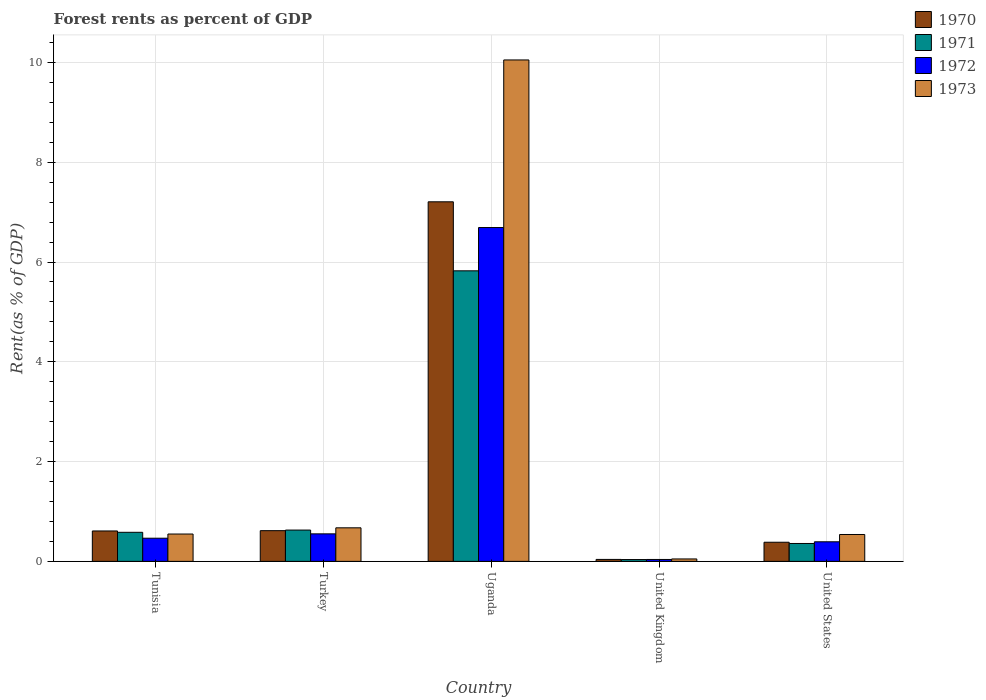How many groups of bars are there?
Keep it short and to the point. 5. Are the number of bars on each tick of the X-axis equal?
Offer a very short reply. Yes. How many bars are there on the 4th tick from the left?
Your response must be concise. 4. How many bars are there on the 1st tick from the right?
Ensure brevity in your answer.  4. What is the label of the 2nd group of bars from the left?
Offer a terse response. Turkey. What is the forest rent in 1973 in Tunisia?
Give a very brief answer. 0.55. Across all countries, what is the maximum forest rent in 1971?
Provide a succinct answer. 5.82. Across all countries, what is the minimum forest rent in 1972?
Provide a short and direct response. 0.04. In which country was the forest rent in 1970 maximum?
Your answer should be compact. Uganda. What is the total forest rent in 1972 in the graph?
Give a very brief answer. 8.14. What is the difference between the forest rent in 1972 in Uganda and that in United Kingdom?
Keep it short and to the point. 6.65. What is the difference between the forest rent in 1972 in Turkey and the forest rent in 1971 in Uganda?
Keep it short and to the point. -5.27. What is the average forest rent in 1971 per country?
Your response must be concise. 1.49. What is the difference between the forest rent of/in 1973 and forest rent of/in 1971 in United Kingdom?
Your answer should be very brief. 0.01. What is the ratio of the forest rent in 1971 in Uganda to that in United Kingdom?
Ensure brevity in your answer.  160.46. Is the difference between the forest rent in 1973 in Turkey and United Kingdom greater than the difference between the forest rent in 1971 in Turkey and United Kingdom?
Provide a short and direct response. Yes. What is the difference between the highest and the second highest forest rent in 1971?
Give a very brief answer. 0.04. What is the difference between the highest and the lowest forest rent in 1972?
Offer a very short reply. 6.65. Is the sum of the forest rent in 1972 in United Kingdom and United States greater than the maximum forest rent in 1973 across all countries?
Offer a very short reply. No. Is it the case that in every country, the sum of the forest rent in 1970 and forest rent in 1972 is greater than the sum of forest rent in 1971 and forest rent in 1973?
Give a very brief answer. No. Is it the case that in every country, the sum of the forest rent in 1972 and forest rent in 1970 is greater than the forest rent in 1971?
Provide a succinct answer. Yes. Are all the bars in the graph horizontal?
Ensure brevity in your answer.  No. What is the difference between two consecutive major ticks on the Y-axis?
Make the answer very short. 2. Does the graph contain grids?
Offer a terse response. Yes. How are the legend labels stacked?
Make the answer very short. Vertical. What is the title of the graph?
Your response must be concise. Forest rents as percent of GDP. What is the label or title of the Y-axis?
Your response must be concise. Rent(as % of GDP). What is the Rent(as % of GDP) in 1970 in Tunisia?
Your answer should be very brief. 0.61. What is the Rent(as % of GDP) of 1971 in Tunisia?
Offer a terse response. 0.58. What is the Rent(as % of GDP) of 1972 in Tunisia?
Your answer should be very brief. 0.46. What is the Rent(as % of GDP) in 1973 in Tunisia?
Make the answer very short. 0.55. What is the Rent(as % of GDP) of 1970 in Turkey?
Ensure brevity in your answer.  0.62. What is the Rent(as % of GDP) in 1971 in Turkey?
Your answer should be very brief. 0.63. What is the Rent(as % of GDP) in 1972 in Turkey?
Your answer should be very brief. 0.55. What is the Rent(as % of GDP) of 1973 in Turkey?
Your answer should be compact. 0.67. What is the Rent(as % of GDP) of 1970 in Uganda?
Ensure brevity in your answer.  7.21. What is the Rent(as % of GDP) of 1971 in Uganda?
Offer a very short reply. 5.82. What is the Rent(as % of GDP) of 1972 in Uganda?
Your answer should be compact. 6.69. What is the Rent(as % of GDP) of 1973 in Uganda?
Your answer should be compact. 10.05. What is the Rent(as % of GDP) in 1970 in United Kingdom?
Offer a very short reply. 0.04. What is the Rent(as % of GDP) of 1971 in United Kingdom?
Provide a succinct answer. 0.04. What is the Rent(as % of GDP) in 1972 in United Kingdom?
Provide a short and direct response. 0.04. What is the Rent(as % of GDP) in 1973 in United Kingdom?
Provide a short and direct response. 0.05. What is the Rent(as % of GDP) in 1970 in United States?
Your answer should be compact. 0.38. What is the Rent(as % of GDP) in 1971 in United States?
Your response must be concise. 0.36. What is the Rent(as % of GDP) of 1972 in United States?
Your answer should be very brief. 0.39. What is the Rent(as % of GDP) in 1973 in United States?
Offer a terse response. 0.54. Across all countries, what is the maximum Rent(as % of GDP) in 1970?
Ensure brevity in your answer.  7.21. Across all countries, what is the maximum Rent(as % of GDP) of 1971?
Make the answer very short. 5.82. Across all countries, what is the maximum Rent(as % of GDP) in 1972?
Provide a short and direct response. 6.69. Across all countries, what is the maximum Rent(as % of GDP) of 1973?
Provide a short and direct response. 10.05. Across all countries, what is the minimum Rent(as % of GDP) of 1970?
Give a very brief answer. 0.04. Across all countries, what is the minimum Rent(as % of GDP) in 1971?
Your answer should be very brief. 0.04. Across all countries, what is the minimum Rent(as % of GDP) of 1972?
Provide a succinct answer. 0.04. Across all countries, what is the minimum Rent(as % of GDP) of 1973?
Provide a succinct answer. 0.05. What is the total Rent(as % of GDP) in 1970 in the graph?
Your answer should be compact. 8.85. What is the total Rent(as % of GDP) in 1971 in the graph?
Your response must be concise. 7.43. What is the total Rent(as % of GDP) of 1972 in the graph?
Give a very brief answer. 8.14. What is the total Rent(as % of GDP) in 1973 in the graph?
Provide a succinct answer. 11.86. What is the difference between the Rent(as % of GDP) of 1970 in Tunisia and that in Turkey?
Provide a short and direct response. -0.01. What is the difference between the Rent(as % of GDP) of 1971 in Tunisia and that in Turkey?
Give a very brief answer. -0.04. What is the difference between the Rent(as % of GDP) in 1972 in Tunisia and that in Turkey?
Offer a terse response. -0.09. What is the difference between the Rent(as % of GDP) in 1973 in Tunisia and that in Turkey?
Your answer should be compact. -0.12. What is the difference between the Rent(as % of GDP) of 1970 in Tunisia and that in Uganda?
Ensure brevity in your answer.  -6.6. What is the difference between the Rent(as % of GDP) in 1971 in Tunisia and that in Uganda?
Make the answer very short. -5.24. What is the difference between the Rent(as % of GDP) in 1972 in Tunisia and that in Uganda?
Offer a very short reply. -6.23. What is the difference between the Rent(as % of GDP) of 1973 in Tunisia and that in Uganda?
Keep it short and to the point. -9.5. What is the difference between the Rent(as % of GDP) in 1970 in Tunisia and that in United Kingdom?
Your response must be concise. 0.57. What is the difference between the Rent(as % of GDP) in 1971 in Tunisia and that in United Kingdom?
Your answer should be very brief. 0.55. What is the difference between the Rent(as % of GDP) of 1972 in Tunisia and that in United Kingdom?
Give a very brief answer. 0.43. What is the difference between the Rent(as % of GDP) of 1973 in Tunisia and that in United Kingdom?
Your response must be concise. 0.5. What is the difference between the Rent(as % of GDP) in 1970 in Tunisia and that in United States?
Provide a short and direct response. 0.23. What is the difference between the Rent(as % of GDP) of 1971 in Tunisia and that in United States?
Make the answer very short. 0.22. What is the difference between the Rent(as % of GDP) of 1972 in Tunisia and that in United States?
Offer a very short reply. 0.07. What is the difference between the Rent(as % of GDP) in 1973 in Tunisia and that in United States?
Offer a terse response. 0.01. What is the difference between the Rent(as % of GDP) in 1970 in Turkey and that in Uganda?
Give a very brief answer. -6.59. What is the difference between the Rent(as % of GDP) of 1971 in Turkey and that in Uganda?
Ensure brevity in your answer.  -5.2. What is the difference between the Rent(as % of GDP) of 1972 in Turkey and that in Uganda?
Offer a terse response. -6.14. What is the difference between the Rent(as % of GDP) in 1973 in Turkey and that in Uganda?
Keep it short and to the point. -9.38. What is the difference between the Rent(as % of GDP) in 1970 in Turkey and that in United Kingdom?
Offer a very short reply. 0.58. What is the difference between the Rent(as % of GDP) in 1971 in Turkey and that in United Kingdom?
Keep it short and to the point. 0.59. What is the difference between the Rent(as % of GDP) of 1972 in Turkey and that in United Kingdom?
Your response must be concise. 0.51. What is the difference between the Rent(as % of GDP) of 1973 in Turkey and that in United Kingdom?
Provide a succinct answer. 0.62. What is the difference between the Rent(as % of GDP) in 1970 in Turkey and that in United States?
Offer a very short reply. 0.23. What is the difference between the Rent(as % of GDP) in 1971 in Turkey and that in United States?
Your answer should be compact. 0.27. What is the difference between the Rent(as % of GDP) in 1972 in Turkey and that in United States?
Your answer should be compact. 0.16. What is the difference between the Rent(as % of GDP) in 1973 in Turkey and that in United States?
Provide a short and direct response. 0.13. What is the difference between the Rent(as % of GDP) in 1970 in Uganda and that in United Kingdom?
Ensure brevity in your answer.  7.17. What is the difference between the Rent(as % of GDP) of 1971 in Uganda and that in United Kingdom?
Your answer should be very brief. 5.79. What is the difference between the Rent(as % of GDP) of 1972 in Uganda and that in United Kingdom?
Ensure brevity in your answer.  6.65. What is the difference between the Rent(as % of GDP) in 1973 in Uganda and that in United Kingdom?
Ensure brevity in your answer.  10. What is the difference between the Rent(as % of GDP) in 1970 in Uganda and that in United States?
Provide a short and direct response. 6.82. What is the difference between the Rent(as % of GDP) in 1971 in Uganda and that in United States?
Keep it short and to the point. 5.47. What is the difference between the Rent(as % of GDP) of 1972 in Uganda and that in United States?
Keep it short and to the point. 6.3. What is the difference between the Rent(as % of GDP) in 1973 in Uganda and that in United States?
Your response must be concise. 9.51. What is the difference between the Rent(as % of GDP) in 1970 in United Kingdom and that in United States?
Your answer should be compact. -0.34. What is the difference between the Rent(as % of GDP) in 1971 in United Kingdom and that in United States?
Make the answer very short. -0.32. What is the difference between the Rent(as % of GDP) of 1972 in United Kingdom and that in United States?
Provide a succinct answer. -0.35. What is the difference between the Rent(as % of GDP) in 1973 in United Kingdom and that in United States?
Provide a short and direct response. -0.49. What is the difference between the Rent(as % of GDP) of 1970 in Tunisia and the Rent(as % of GDP) of 1971 in Turkey?
Ensure brevity in your answer.  -0.02. What is the difference between the Rent(as % of GDP) of 1970 in Tunisia and the Rent(as % of GDP) of 1972 in Turkey?
Offer a terse response. 0.06. What is the difference between the Rent(as % of GDP) of 1970 in Tunisia and the Rent(as % of GDP) of 1973 in Turkey?
Your answer should be compact. -0.06. What is the difference between the Rent(as % of GDP) in 1971 in Tunisia and the Rent(as % of GDP) in 1972 in Turkey?
Make the answer very short. 0.03. What is the difference between the Rent(as % of GDP) of 1971 in Tunisia and the Rent(as % of GDP) of 1973 in Turkey?
Your answer should be compact. -0.09. What is the difference between the Rent(as % of GDP) in 1972 in Tunisia and the Rent(as % of GDP) in 1973 in Turkey?
Your answer should be compact. -0.21. What is the difference between the Rent(as % of GDP) in 1970 in Tunisia and the Rent(as % of GDP) in 1971 in Uganda?
Offer a terse response. -5.21. What is the difference between the Rent(as % of GDP) of 1970 in Tunisia and the Rent(as % of GDP) of 1972 in Uganda?
Make the answer very short. -6.08. What is the difference between the Rent(as % of GDP) in 1970 in Tunisia and the Rent(as % of GDP) in 1973 in Uganda?
Provide a short and direct response. -9.44. What is the difference between the Rent(as % of GDP) in 1971 in Tunisia and the Rent(as % of GDP) in 1972 in Uganda?
Offer a terse response. -6.11. What is the difference between the Rent(as % of GDP) of 1971 in Tunisia and the Rent(as % of GDP) of 1973 in Uganda?
Provide a succinct answer. -9.47. What is the difference between the Rent(as % of GDP) of 1972 in Tunisia and the Rent(as % of GDP) of 1973 in Uganda?
Provide a succinct answer. -9.59. What is the difference between the Rent(as % of GDP) in 1970 in Tunisia and the Rent(as % of GDP) in 1971 in United Kingdom?
Provide a short and direct response. 0.57. What is the difference between the Rent(as % of GDP) in 1970 in Tunisia and the Rent(as % of GDP) in 1972 in United Kingdom?
Provide a succinct answer. 0.57. What is the difference between the Rent(as % of GDP) in 1970 in Tunisia and the Rent(as % of GDP) in 1973 in United Kingdom?
Offer a very short reply. 0.56. What is the difference between the Rent(as % of GDP) of 1971 in Tunisia and the Rent(as % of GDP) of 1972 in United Kingdom?
Ensure brevity in your answer.  0.54. What is the difference between the Rent(as % of GDP) of 1971 in Tunisia and the Rent(as % of GDP) of 1973 in United Kingdom?
Offer a terse response. 0.53. What is the difference between the Rent(as % of GDP) of 1972 in Tunisia and the Rent(as % of GDP) of 1973 in United Kingdom?
Provide a succinct answer. 0.42. What is the difference between the Rent(as % of GDP) in 1970 in Tunisia and the Rent(as % of GDP) in 1971 in United States?
Give a very brief answer. 0.25. What is the difference between the Rent(as % of GDP) in 1970 in Tunisia and the Rent(as % of GDP) in 1972 in United States?
Provide a short and direct response. 0.22. What is the difference between the Rent(as % of GDP) in 1970 in Tunisia and the Rent(as % of GDP) in 1973 in United States?
Your answer should be very brief. 0.07. What is the difference between the Rent(as % of GDP) of 1971 in Tunisia and the Rent(as % of GDP) of 1972 in United States?
Keep it short and to the point. 0.19. What is the difference between the Rent(as % of GDP) of 1971 in Tunisia and the Rent(as % of GDP) of 1973 in United States?
Give a very brief answer. 0.04. What is the difference between the Rent(as % of GDP) in 1972 in Tunisia and the Rent(as % of GDP) in 1973 in United States?
Provide a short and direct response. -0.07. What is the difference between the Rent(as % of GDP) of 1970 in Turkey and the Rent(as % of GDP) of 1971 in Uganda?
Make the answer very short. -5.21. What is the difference between the Rent(as % of GDP) in 1970 in Turkey and the Rent(as % of GDP) in 1972 in Uganda?
Your response must be concise. -6.08. What is the difference between the Rent(as % of GDP) in 1970 in Turkey and the Rent(as % of GDP) in 1973 in Uganda?
Your answer should be compact. -9.44. What is the difference between the Rent(as % of GDP) of 1971 in Turkey and the Rent(as % of GDP) of 1972 in Uganda?
Make the answer very short. -6.06. What is the difference between the Rent(as % of GDP) in 1971 in Turkey and the Rent(as % of GDP) in 1973 in Uganda?
Offer a terse response. -9.42. What is the difference between the Rent(as % of GDP) in 1972 in Turkey and the Rent(as % of GDP) in 1973 in Uganda?
Your answer should be compact. -9.5. What is the difference between the Rent(as % of GDP) of 1970 in Turkey and the Rent(as % of GDP) of 1971 in United Kingdom?
Offer a very short reply. 0.58. What is the difference between the Rent(as % of GDP) of 1970 in Turkey and the Rent(as % of GDP) of 1972 in United Kingdom?
Provide a succinct answer. 0.58. What is the difference between the Rent(as % of GDP) in 1970 in Turkey and the Rent(as % of GDP) in 1973 in United Kingdom?
Your response must be concise. 0.57. What is the difference between the Rent(as % of GDP) of 1971 in Turkey and the Rent(as % of GDP) of 1972 in United Kingdom?
Your answer should be compact. 0.59. What is the difference between the Rent(as % of GDP) in 1971 in Turkey and the Rent(as % of GDP) in 1973 in United Kingdom?
Your answer should be very brief. 0.58. What is the difference between the Rent(as % of GDP) in 1972 in Turkey and the Rent(as % of GDP) in 1973 in United Kingdom?
Offer a very short reply. 0.5. What is the difference between the Rent(as % of GDP) in 1970 in Turkey and the Rent(as % of GDP) in 1971 in United States?
Offer a terse response. 0.26. What is the difference between the Rent(as % of GDP) in 1970 in Turkey and the Rent(as % of GDP) in 1972 in United States?
Provide a short and direct response. 0.22. What is the difference between the Rent(as % of GDP) in 1970 in Turkey and the Rent(as % of GDP) in 1973 in United States?
Keep it short and to the point. 0.08. What is the difference between the Rent(as % of GDP) of 1971 in Turkey and the Rent(as % of GDP) of 1972 in United States?
Provide a short and direct response. 0.23. What is the difference between the Rent(as % of GDP) in 1971 in Turkey and the Rent(as % of GDP) in 1973 in United States?
Your answer should be compact. 0.09. What is the difference between the Rent(as % of GDP) in 1972 in Turkey and the Rent(as % of GDP) in 1973 in United States?
Your response must be concise. 0.01. What is the difference between the Rent(as % of GDP) of 1970 in Uganda and the Rent(as % of GDP) of 1971 in United Kingdom?
Keep it short and to the point. 7.17. What is the difference between the Rent(as % of GDP) of 1970 in Uganda and the Rent(as % of GDP) of 1972 in United Kingdom?
Give a very brief answer. 7.17. What is the difference between the Rent(as % of GDP) in 1970 in Uganda and the Rent(as % of GDP) in 1973 in United Kingdom?
Offer a terse response. 7.16. What is the difference between the Rent(as % of GDP) of 1971 in Uganda and the Rent(as % of GDP) of 1972 in United Kingdom?
Offer a very short reply. 5.79. What is the difference between the Rent(as % of GDP) in 1971 in Uganda and the Rent(as % of GDP) in 1973 in United Kingdom?
Your answer should be very brief. 5.78. What is the difference between the Rent(as % of GDP) of 1972 in Uganda and the Rent(as % of GDP) of 1973 in United Kingdom?
Provide a short and direct response. 6.64. What is the difference between the Rent(as % of GDP) in 1970 in Uganda and the Rent(as % of GDP) in 1971 in United States?
Make the answer very short. 6.85. What is the difference between the Rent(as % of GDP) in 1970 in Uganda and the Rent(as % of GDP) in 1972 in United States?
Provide a short and direct response. 6.81. What is the difference between the Rent(as % of GDP) of 1970 in Uganda and the Rent(as % of GDP) of 1973 in United States?
Your response must be concise. 6.67. What is the difference between the Rent(as % of GDP) of 1971 in Uganda and the Rent(as % of GDP) of 1972 in United States?
Offer a very short reply. 5.43. What is the difference between the Rent(as % of GDP) of 1971 in Uganda and the Rent(as % of GDP) of 1973 in United States?
Your response must be concise. 5.29. What is the difference between the Rent(as % of GDP) in 1972 in Uganda and the Rent(as % of GDP) in 1973 in United States?
Ensure brevity in your answer.  6.15. What is the difference between the Rent(as % of GDP) in 1970 in United Kingdom and the Rent(as % of GDP) in 1971 in United States?
Give a very brief answer. -0.32. What is the difference between the Rent(as % of GDP) of 1970 in United Kingdom and the Rent(as % of GDP) of 1972 in United States?
Ensure brevity in your answer.  -0.35. What is the difference between the Rent(as % of GDP) of 1970 in United Kingdom and the Rent(as % of GDP) of 1973 in United States?
Your response must be concise. -0.5. What is the difference between the Rent(as % of GDP) of 1971 in United Kingdom and the Rent(as % of GDP) of 1972 in United States?
Your answer should be compact. -0.36. What is the difference between the Rent(as % of GDP) of 1971 in United Kingdom and the Rent(as % of GDP) of 1973 in United States?
Your response must be concise. -0.5. What is the difference between the Rent(as % of GDP) in 1972 in United Kingdom and the Rent(as % of GDP) in 1973 in United States?
Make the answer very short. -0.5. What is the average Rent(as % of GDP) of 1970 per country?
Your answer should be very brief. 1.77. What is the average Rent(as % of GDP) in 1971 per country?
Offer a very short reply. 1.49. What is the average Rent(as % of GDP) in 1972 per country?
Your answer should be compact. 1.63. What is the average Rent(as % of GDP) in 1973 per country?
Provide a succinct answer. 2.37. What is the difference between the Rent(as % of GDP) of 1970 and Rent(as % of GDP) of 1971 in Tunisia?
Make the answer very short. 0.03. What is the difference between the Rent(as % of GDP) of 1970 and Rent(as % of GDP) of 1972 in Tunisia?
Offer a very short reply. 0.15. What is the difference between the Rent(as % of GDP) in 1970 and Rent(as % of GDP) in 1973 in Tunisia?
Give a very brief answer. 0.06. What is the difference between the Rent(as % of GDP) of 1971 and Rent(as % of GDP) of 1972 in Tunisia?
Make the answer very short. 0.12. What is the difference between the Rent(as % of GDP) of 1971 and Rent(as % of GDP) of 1973 in Tunisia?
Your answer should be compact. 0.03. What is the difference between the Rent(as % of GDP) of 1972 and Rent(as % of GDP) of 1973 in Tunisia?
Offer a very short reply. -0.08. What is the difference between the Rent(as % of GDP) in 1970 and Rent(as % of GDP) in 1971 in Turkey?
Offer a very short reply. -0.01. What is the difference between the Rent(as % of GDP) in 1970 and Rent(as % of GDP) in 1972 in Turkey?
Your response must be concise. 0.06. What is the difference between the Rent(as % of GDP) in 1970 and Rent(as % of GDP) in 1973 in Turkey?
Keep it short and to the point. -0.06. What is the difference between the Rent(as % of GDP) of 1971 and Rent(as % of GDP) of 1972 in Turkey?
Your response must be concise. 0.08. What is the difference between the Rent(as % of GDP) of 1971 and Rent(as % of GDP) of 1973 in Turkey?
Provide a succinct answer. -0.05. What is the difference between the Rent(as % of GDP) in 1972 and Rent(as % of GDP) in 1973 in Turkey?
Keep it short and to the point. -0.12. What is the difference between the Rent(as % of GDP) of 1970 and Rent(as % of GDP) of 1971 in Uganda?
Keep it short and to the point. 1.38. What is the difference between the Rent(as % of GDP) in 1970 and Rent(as % of GDP) in 1972 in Uganda?
Your answer should be very brief. 0.52. What is the difference between the Rent(as % of GDP) of 1970 and Rent(as % of GDP) of 1973 in Uganda?
Ensure brevity in your answer.  -2.84. What is the difference between the Rent(as % of GDP) of 1971 and Rent(as % of GDP) of 1972 in Uganda?
Your response must be concise. -0.87. What is the difference between the Rent(as % of GDP) in 1971 and Rent(as % of GDP) in 1973 in Uganda?
Your answer should be very brief. -4.23. What is the difference between the Rent(as % of GDP) of 1972 and Rent(as % of GDP) of 1973 in Uganda?
Keep it short and to the point. -3.36. What is the difference between the Rent(as % of GDP) in 1970 and Rent(as % of GDP) in 1971 in United Kingdom?
Offer a terse response. 0. What is the difference between the Rent(as % of GDP) in 1970 and Rent(as % of GDP) in 1972 in United Kingdom?
Give a very brief answer. 0. What is the difference between the Rent(as % of GDP) in 1970 and Rent(as % of GDP) in 1973 in United Kingdom?
Provide a succinct answer. -0.01. What is the difference between the Rent(as % of GDP) in 1971 and Rent(as % of GDP) in 1972 in United Kingdom?
Give a very brief answer. -0. What is the difference between the Rent(as % of GDP) in 1971 and Rent(as % of GDP) in 1973 in United Kingdom?
Keep it short and to the point. -0.01. What is the difference between the Rent(as % of GDP) of 1972 and Rent(as % of GDP) of 1973 in United Kingdom?
Keep it short and to the point. -0.01. What is the difference between the Rent(as % of GDP) of 1970 and Rent(as % of GDP) of 1971 in United States?
Ensure brevity in your answer.  0.02. What is the difference between the Rent(as % of GDP) in 1970 and Rent(as % of GDP) in 1972 in United States?
Provide a succinct answer. -0.01. What is the difference between the Rent(as % of GDP) of 1970 and Rent(as % of GDP) of 1973 in United States?
Your response must be concise. -0.16. What is the difference between the Rent(as % of GDP) of 1971 and Rent(as % of GDP) of 1972 in United States?
Offer a very short reply. -0.03. What is the difference between the Rent(as % of GDP) of 1971 and Rent(as % of GDP) of 1973 in United States?
Give a very brief answer. -0.18. What is the difference between the Rent(as % of GDP) of 1972 and Rent(as % of GDP) of 1973 in United States?
Your answer should be very brief. -0.15. What is the ratio of the Rent(as % of GDP) of 1970 in Tunisia to that in Turkey?
Make the answer very short. 0.99. What is the ratio of the Rent(as % of GDP) in 1971 in Tunisia to that in Turkey?
Your answer should be very brief. 0.93. What is the ratio of the Rent(as % of GDP) in 1972 in Tunisia to that in Turkey?
Keep it short and to the point. 0.84. What is the ratio of the Rent(as % of GDP) of 1973 in Tunisia to that in Turkey?
Provide a short and direct response. 0.81. What is the ratio of the Rent(as % of GDP) in 1970 in Tunisia to that in Uganda?
Ensure brevity in your answer.  0.08. What is the ratio of the Rent(as % of GDP) in 1972 in Tunisia to that in Uganda?
Provide a succinct answer. 0.07. What is the ratio of the Rent(as % of GDP) of 1973 in Tunisia to that in Uganda?
Keep it short and to the point. 0.05. What is the ratio of the Rent(as % of GDP) of 1970 in Tunisia to that in United Kingdom?
Provide a short and direct response. 15.63. What is the ratio of the Rent(as % of GDP) of 1971 in Tunisia to that in United Kingdom?
Offer a terse response. 16.05. What is the ratio of the Rent(as % of GDP) in 1972 in Tunisia to that in United Kingdom?
Provide a short and direct response. 12.2. What is the ratio of the Rent(as % of GDP) in 1973 in Tunisia to that in United Kingdom?
Ensure brevity in your answer.  11.27. What is the ratio of the Rent(as % of GDP) of 1970 in Tunisia to that in United States?
Offer a terse response. 1.59. What is the ratio of the Rent(as % of GDP) in 1971 in Tunisia to that in United States?
Your response must be concise. 1.62. What is the ratio of the Rent(as % of GDP) of 1972 in Tunisia to that in United States?
Make the answer very short. 1.18. What is the ratio of the Rent(as % of GDP) of 1973 in Tunisia to that in United States?
Provide a succinct answer. 1.02. What is the ratio of the Rent(as % of GDP) in 1970 in Turkey to that in Uganda?
Your answer should be very brief. 0.09. What is the ratio of the Rent(as % of GDP) in 1971 in Turkey to that in Uganda?
Offer a very short reply. 0.11. What is the ratio of the Rent(as % of GDP) in 1972 in Turkey to that in Uganda?
Keep it short and to the point. 0.08. What is the ratio of the Rent(as % of GDP) in 1973 in Turkey to that in Uganda?
Your response must be concise. 0.07. What is the ratio of the Rent(as % of GDP) of 1970 in Turkey to that in United Kingdom?
Ensure brevity in your answer.  15.78. What is the ratio of the Rent(as % of GDP) in 1971 in Turkey to that in United Kingdom?
Ensure brevity in your answer.  17.29. What is the ratio of the Rent(as % of GDP) in 1972 in Turkey to that in United Kingdom?
Keep it short and to the point. 14.49. What is the ratio of the Rent(as % of GDP) of 1973 in Turkey to that in United Kingdom?
Make the answer very short. 13.83. What is the ratio of the Rent(as % of GDP) in 1970 in Turkey to that in United States?
Offer a very short reply. 1.61. What is the ratio of the Rent(as % of GDP) of 1971 in Turkey to that in United States?
Offer a very short reply. 1.75. What is the ratio of the Rent(as % of GDP) in 1972 in Turkey to that in United States?
Provide a succinct answer. 1.41. What is the ratio of the Rent(as % of GDP) of 1973 in Turkey to that in United States?
Your answer should be very brief. 1.25. What is the ratio of the Rent(as % of GDP) in 1970 in Uganda to that in United Kingdom?
Provide a succinct answer. 184.81. What is the ratio of the Rent(as % of GDP) of 1971 in Uganda to that in United Kingdom?
Keep it short and to the point. 160.46. What is the ratio of the Rent(as % of GDP) in 1972 in Uganda to that in United Kingdom?
Make the answer very short. 175.86. What is the ratio of the Rent(as % of GDP) in 1973 in Uganda to that in United Kingdom?
Offer a very short reply. 206.75. What is the ratio of the Rent(as % of GDP) of 1970 in Uganda to that in United States?
Give a very brief answer. 18.8. What is the ratio of the Rent(as % of GDP) in 1971 in Uganda to that in United States?
Give a very brief answer. 16.24. What is the ratio of the Rent(as % of GDP) in 1972 in Uganda to that in United States?
Your answer should be compact. 17.05. What is the ratio of the Rent(as % of GDP) in 1973 in Uganda to that in United States?
Make the answer very short. 18.66. What is the ratio of the Rent(as % of GDP) in 1970 in United Kingdom to that in United States?
Provide a succinct answer. 0.1. What is the ratio of the Rent(as % of GDP) in 1971 in United Kingdom to that in United States?
Your answer should be very brief. 0.1. What is the ratio of the Rent(as % of GDP) of 1972 in United Kingdom to that in United States?
Make the answer very short. 0.1. What is the ratio of the Rent(as % of GDP) of 1973 in United Kingdom to that in United States?
Keep it short and to the point. 0.09. What is the difference between the highest and the second highest Rent(as % of GDP) of 1970?
Provide a short and direct response. 6.59. What is the difference between the highest and the second highest Rent(as % of GDP) of 1971?
Give a very brief answer. 5.2. What is the difference between the highest and the second highest Rent(as % of GDP) of 1972?
Your answer should be very brief. 6.14. What is the difference between the highest and the second highest Rent(as % of GDP) in 1973?
Provide a short and direct response. 9.38. What is the difference between the highest and the lowest Rent(as % of GDP) in 1970?
Offer a terse response. 7.17. What is the difference between the highest and the lowest Rent(as % of GDP) of 1971?
Offer a terse response. 5.79. What is the difference between the highest and the lowest Rent(as % of GDP) in 1972?
Offer a terse response. 6.65. What is the difference between the highest and the lowest Rent(as % of GDP) in 1973?
Keep it short and to the point. 10. 